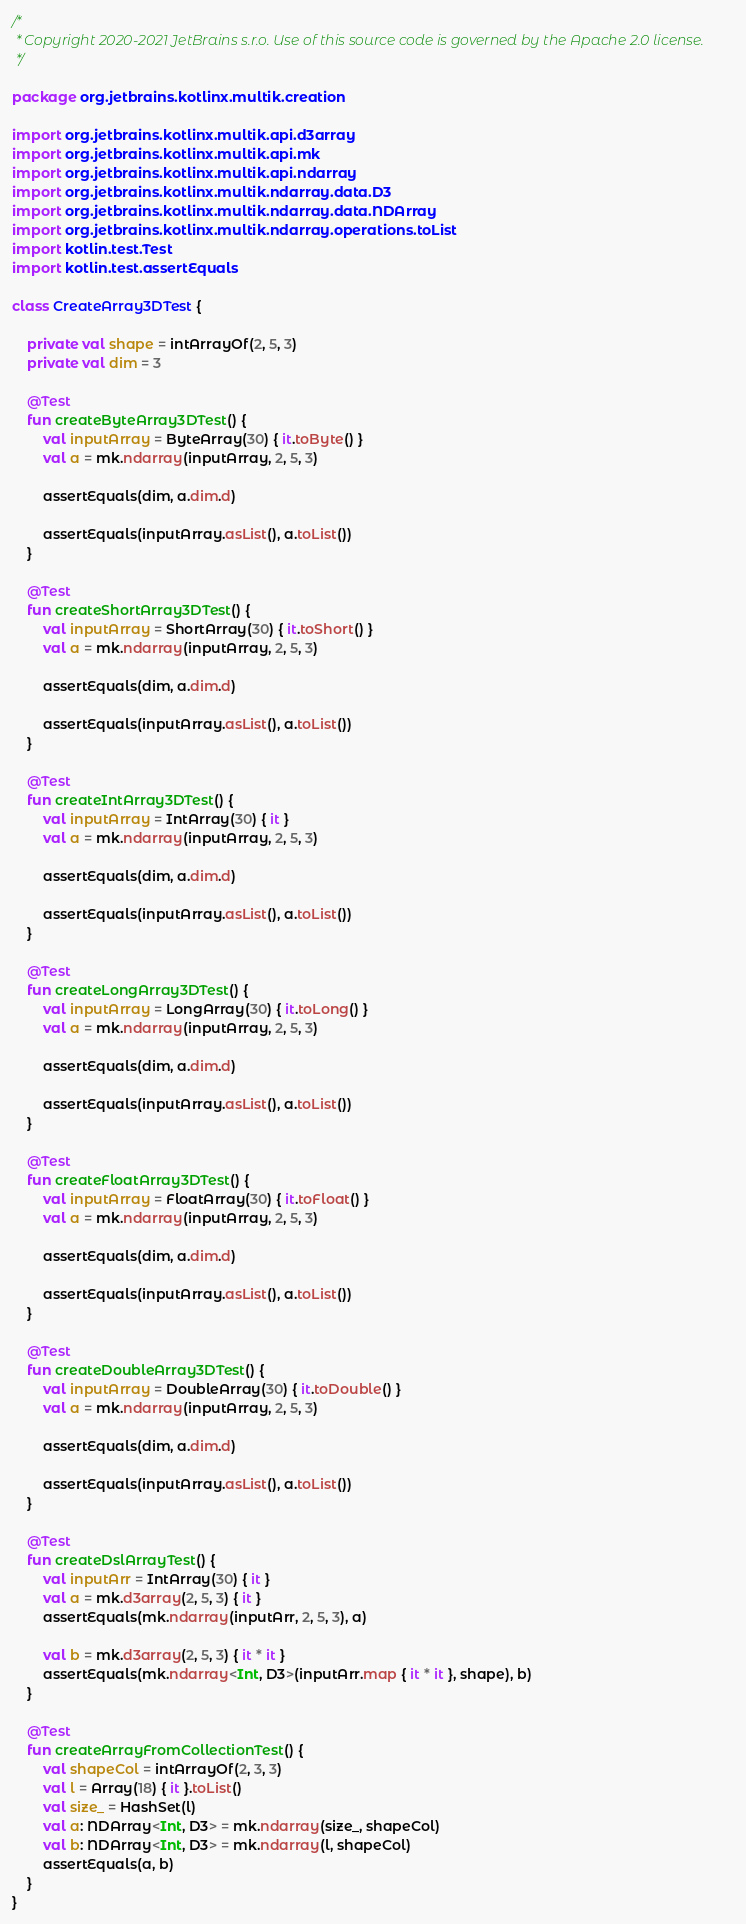Convert code to text. <code><loc_0><loc_0><loc_500><loc_500><_Kotlin_>/*
 * Copyright 2020-2021 JetBrains s.r.o. Use of this source code is governed by the Apache 2.0 license.
 */

package org.jetbrains.kotlinx.multik.creation

import org.jetbrains.kotlinx.multik.api.d3array
import org.jetbrains.kotlinx.multik.api.mk
import org.jetbrains.kotlinx.multik.api.ndarray
import org.jetbrains.kotlinx.multik.ndarray.data.D3
import org.jetbrains.kotlinx.multik.ndarray.data.NDArray
import org.jetbrains.kotlinx.multik.ndarray.operations.toList
import kotlin.test.Test
import kotlin.test.assertEquals

class CreateArray3DTest {

    private val shape = intArrayOf(2, 5, 3)
    private val dim = 3

    @Test
    fun createByteArray3DTest() {
        val inputArray = ByteArray(30) { it.toByte() }
        val a = mk.ndarray(inputArray, 2, 5, 3)

        assertEquals(dim, a.dim.d)

        assertEquals(inputArray.asList(), a.toList())
    }

    @Test
    fun createShortArray3DTest() {
        val inputArray = ShortArray(30) { it.toShort() }
        val a = mk.ndarray(inputArray, 2, 5, 3)

        assertEquals(dim, a.dim.d)

        assertEquals(inputArray.asList(), a.toList())
    }

    @Test
    fun createIntArray3DTest() {
        val inputArray = IntArray(30) { it }
        val a = mk.ndarray(inputArray, 2, 5, 3)

        assertEquals(dim, a.dim.d)

        assertEquals(inputArray.asList(), a.toList())
    }

    @Test
    fun createLongArray3DTest() {
        val inputArray = LongArray(30) { it.toLong() }
        val a = mk.ndarray(inputArray, 2, 5, 3)

        assertEquals(dim, a.dim.d)

        assertEquals(inputArray.asList(), a.toList())
    }

    @Test
    fun createFloatArray3DTest() {
        val inputArray = FloatArray(30) { it.toFloat() }
        val a = mk.ndarray(inputArray, 2, 5, 3)

        assertEquals(dim, a.dim.d)

        assertEquals(inputArray.asList(), a.toList())
    }

    @Test
    fun createDoubleArray3DTest() {
        val inputArray = DoubleArray(30) { it.toDouble() }
        val a = mk.ndarray(inputArray, 2, 5, 3)

        assertEquals(dim, a.dim.d)

        assertEquals(inputArray.asList(), a.toList())
    }

    @Test
    fun createDslArrayTest() {
        val inputArr = IntArray(30) { it }
        val a = mk.d3array(2, 5, 3) { it }
        assertEquals(mk.ndarray(inputArr, 2, 5, 3), a)

        val b = mk.d3array(2, 5, 3) { it * it }
        assertEquals(mk.ndarray<Int, D3>(inputArr.map { it * it }, shape), b)
    }

    @Test
    fun createArrayFromCollectionTest() {
        val shapeCol = intArrayOf(2, 3, 3)
        val l = Array(18) { it }.toList()
        val size_ = HashSet(l)
        val a: NDArray<Int, D3> = mk.ndarray(size_, shapeCol)
        val b: NDArray<Int, D3> = mk.ndarray(l, shapeCol)
        assertEquals(a, b)
    }
}
</code> 